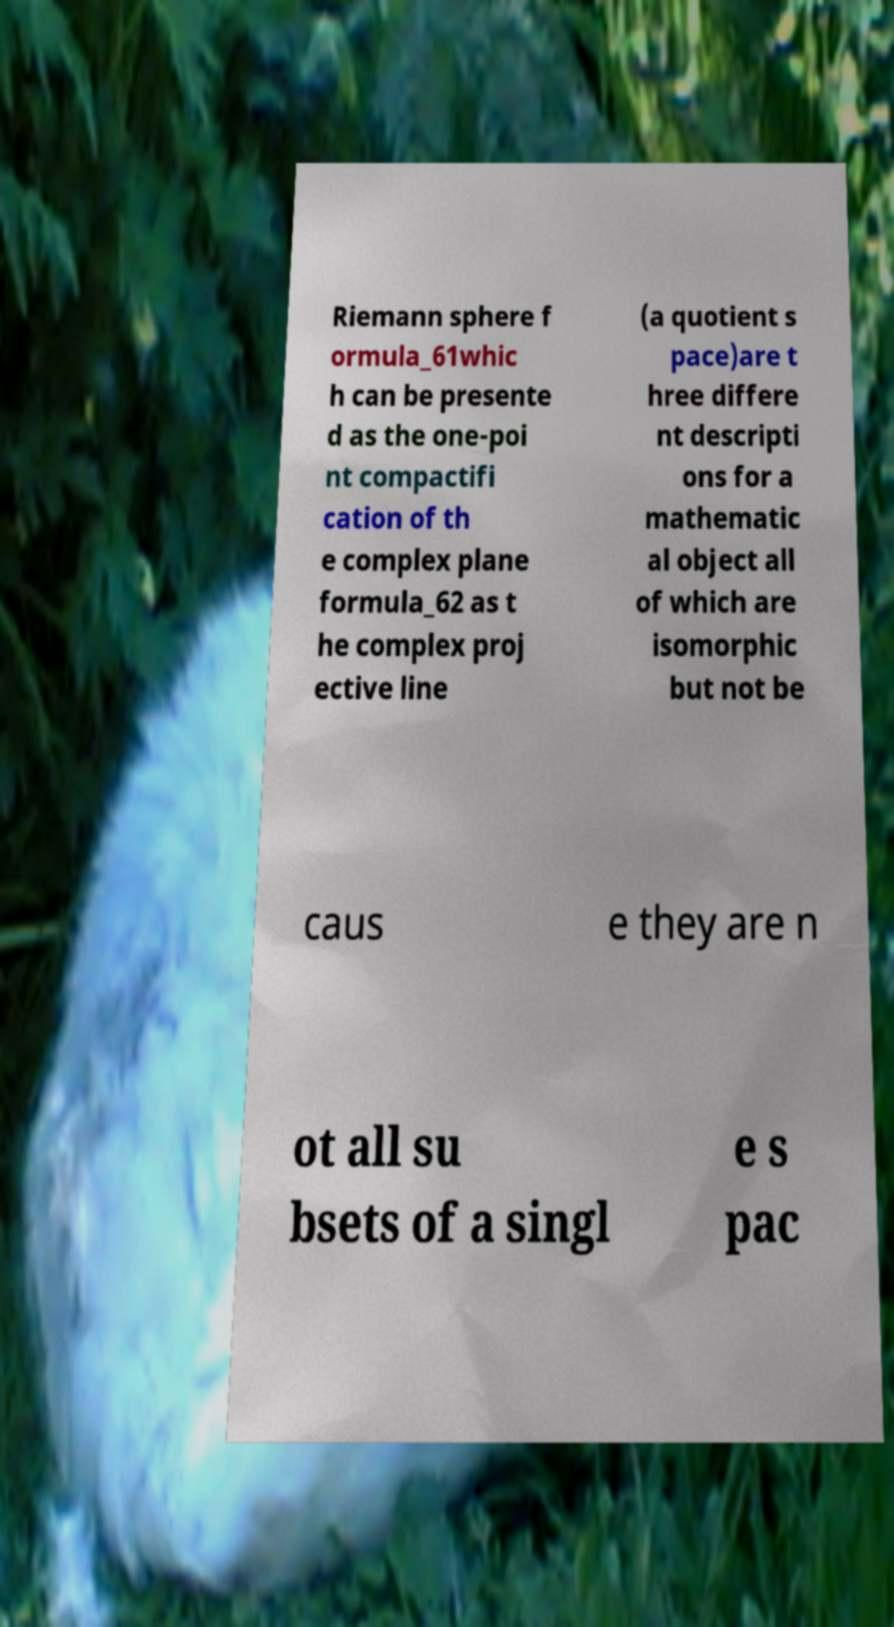Please identify and transcribe the text found in this image. Riemann sphere f ormula_61whic h can be presente d as the one-poi nt compactifi cation of th e complex plane formula_62 as t he complex proj ective line (a quotient s pace)are t hree differe nt descripti ons for a mathematic al object all of which are isomorphic but not be caus e they are n ot all su bsets of a singl e s pac 